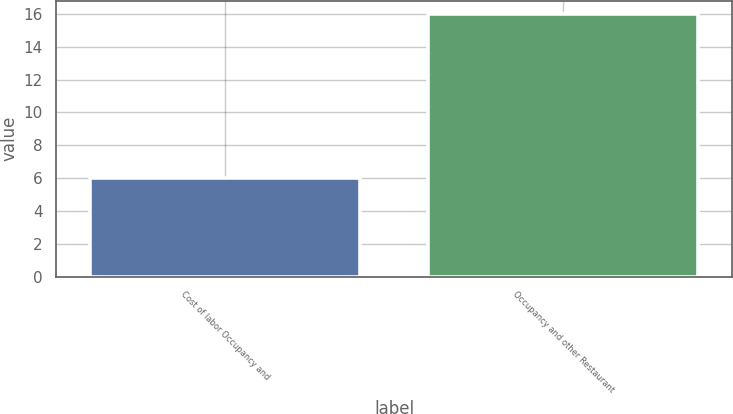Convert chart to OTSL. <chart><loc_0><loc_0><loc_500><loc_500><bar_chart><fcel>Cost of labor Occupancy and<fcel>Occupancy and other Restaurant<nl><fcel>6<fcel>16<nl></chart> 